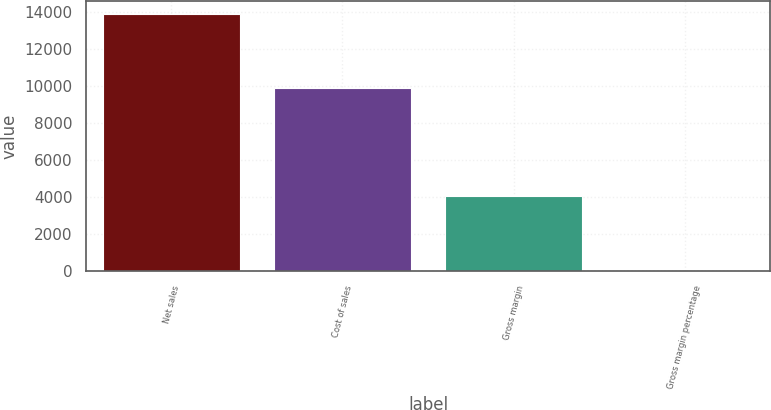<chart> <loc_0><loc_0><loc_500><loc_500><bar_chart><fcel>Net sales<fcel>Cost of sales<fcel>Gross margin<fcel>Gross margin percentage<nl><fcel>13931<fcel>9889<fcel>4042<fcel>29<nl></chart> 